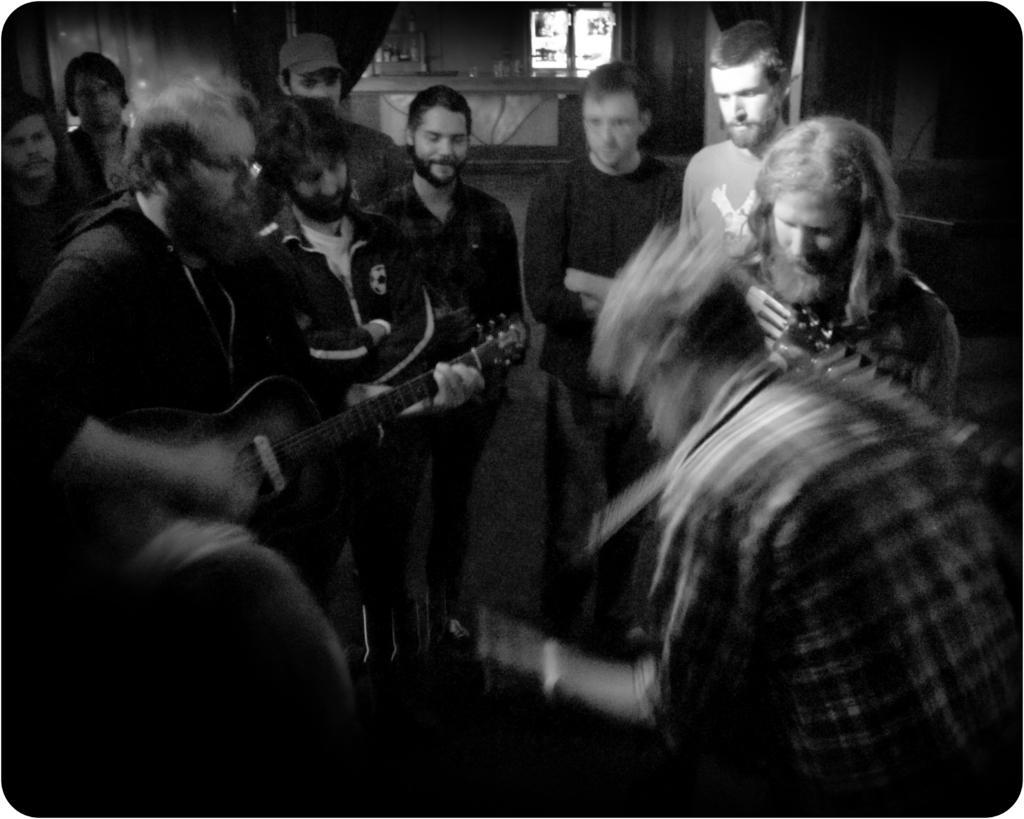How would you summarize this image in a sentence or two? This image is taken indoors. On the left side of the image a man is playing the music with a guitar. On the right side of the image a man is singing. In the background a few people are standing on the floor and there is a wall with a window. 